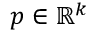Convert formula to latex. <formula><loc_0><loc_0><loc_500><loc_500>p \in \mathbb { R } ^ { k }</formula> 